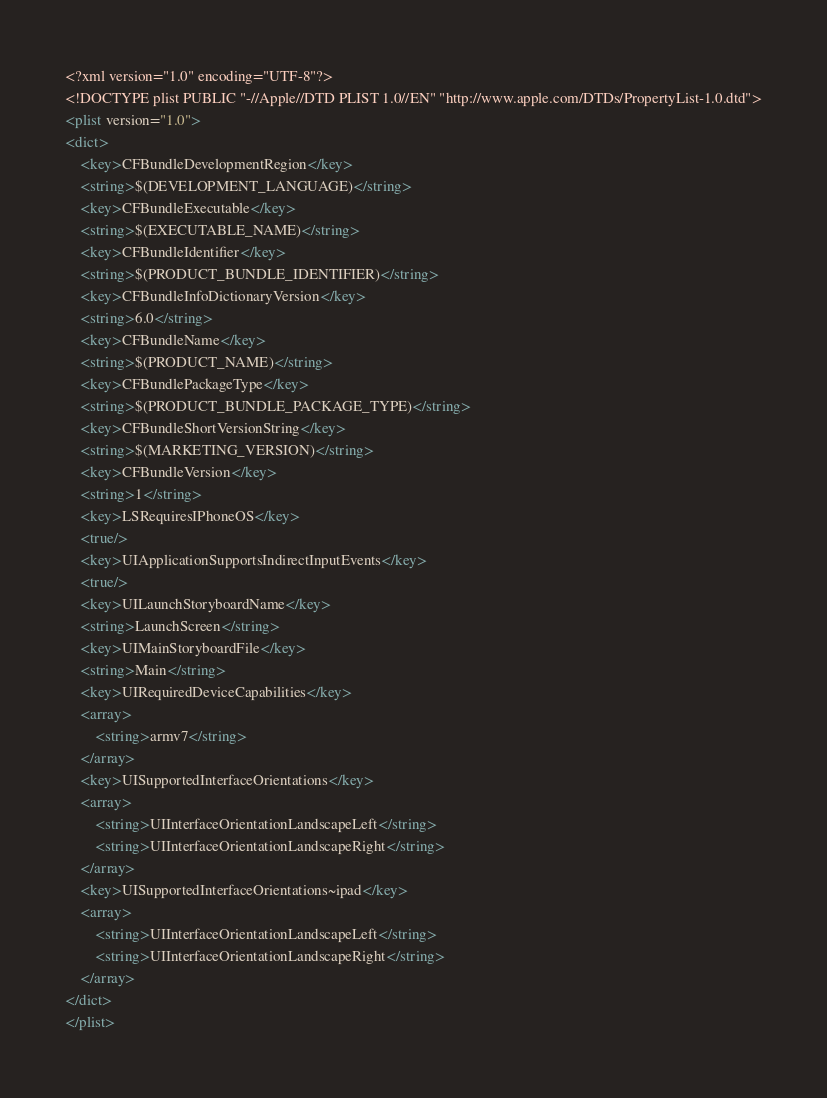<code> <loc_0><loc_0><loc_500><loc_500><_XML_><?xml version="1.0" encoding="UTF-8"?>
<!DOCTYPE plist PUBLIC "-//Apple//DTD PLIST 1.0//EN" "http://www.apple.com/DTDs/PropertyList-1.0.dtd">
<plist version="1.0">
<dict>
	<key>CFBundleDevelopmentRegion</key>
	<string>$(DEVELOPMENT_LANGUAGE)</string>
	<key>CFBundleExecutable</key>
	<string>$(EXECUTABLE_NAME)</string>
	<key>CFBundleIdentifier</key>
	<string>$(PRODUCT_BUNDLE_IDENTIFIER)</string>
	<key>CFBundleInfoDictionaryVersion</key>
	<string>6.0</string>
	<key>CFBundleName</key>
	<string>$(PRODUCT_NAME)</string>
	<key>CFBundlePackageType</key>
	<string>$(PRODUCT_BUNDLE_PACKAGE_TYPE)</string>
	<key>CFBundleShortVersionString</key>
	<string>$(MARKETING_VERSION)</string>
	<key>CFBundleVersion</key>
	<string>1</string>
	<key>LSRequiresIPhoneOS</key>
	<true/>
	<key>UIApplicationSupportsIndirectInputEvents</key>
	<true/>
	<key>UILaunchStoryboardName</key>
	<string>LaunchScreen</string>
	<key>UIMainStoryboardFile</key>
	<string>Main</string>
	<key>UIRequiredDeviceCapabilities</key>
	<array>
		<string>armv7</string>
	</array>
	<key>UISupportedInterfaceOrientations</key>
	<array>
		<string>UIInterfaceOrientationLandscapeLeft</string>
		<string>UIInterfaceOrientationLandscapeRight</string>
	</array>
	<key>UISupportedInterfaceOrientations~ipad</key>
	<array>
		<string>UIInterfaceOrientationLandscapeLeft</string>
		<string>UIInterfaceOrientationLandscapeRight</string>
	</array>
</dict>
</plist>
</code> 